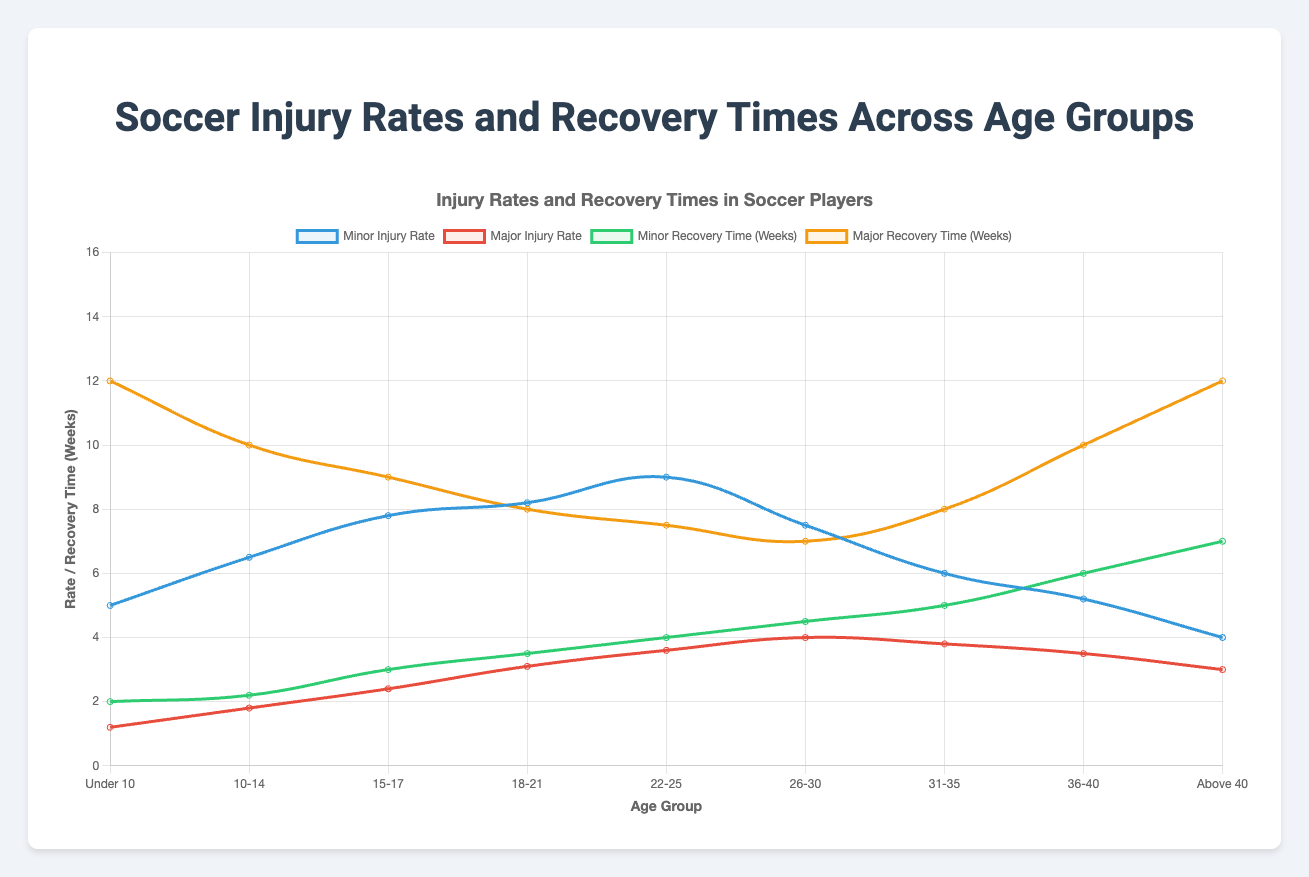Which age group has the highest minor injury rate? Upon observing the figure, we see that the highest peak in the minor injury rate line (which is colored in blue) is for the 22-25 age group.
Answer: 22-25 Which age group has the longest minor recovery time? The green line, representing minor recovery time, is at its highest point for the "Above 40" age group.
Answer: Above 40 What's the difference in major injury rates between the 15-17 and 31-35 age groups? The major injury rate for the 15-17 age group is 2.4, and for the 31-35 age group is 3.8. Subtracting these values: 3.8 - 2.4 = 1.4
Answer: 1.4 Which age group has the shortest major recovery time? The orange line represents the major recovery time, and the lowest point is for the 22-25 age group, which is 7.5 weeks.
Answer: 22-25 How do the minor injury rates for the 10-14 and 26-30 age groups compare? Observing the blue line, the minor injury rate for age group 10-14 is 6.5, and for age group 26-30, it is 7.5. Hence, 26-30 has a higher minor injury rate compared to 10-14.
Answer: 26-30 is higher What is the total recovery time for minor injuries in the 18-21 age group across all age groups? The minor recovery time for 18-21 is 3.5 weeks, summing all the minor recovery times shown (2.0 + 2.2 + 3.0 + 3.5 + 4.0 + 4.5 + 5.0 + 6.0 + 7.0) equals 37.2 weeks.
Answer: 37.2 Between the under 10 and 36-40 age groups, which has a longer minor recovery time? The green line for minor recovery time points to 2.0 weeks for Under 10 and 6.0 weeks for 36-40. Therefore, 36-40 has a longer minor recovery time.
Answer: 36-40 Which age group shows the greatest major injury rate? By examining the red line which indicates major injury rates, the highest peak is for the 26-30 age group, at 4.0.
Answer: 26-30 What is the average major recovery time across all age groups? The major recovery times across all age groups are (12.0, 10.0, 9.0, 8.0, 7.5, 7.0, 8.0, 10.0, 12.0). Summing them gives 83.5 and dividing by the number of age groups (9) gives an average of 83.5 / 9 ≈ 9.3 weeks.
Answer: 9.3 